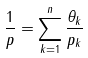Convert formula to latex. <formula><loc_0><loc_0><loc_500><loc_500>\frac { 1 } { p } = \sum _ { k = 1 } ^ { n } \frac { \theta _ { k } } { p _ { k } }</formula> 